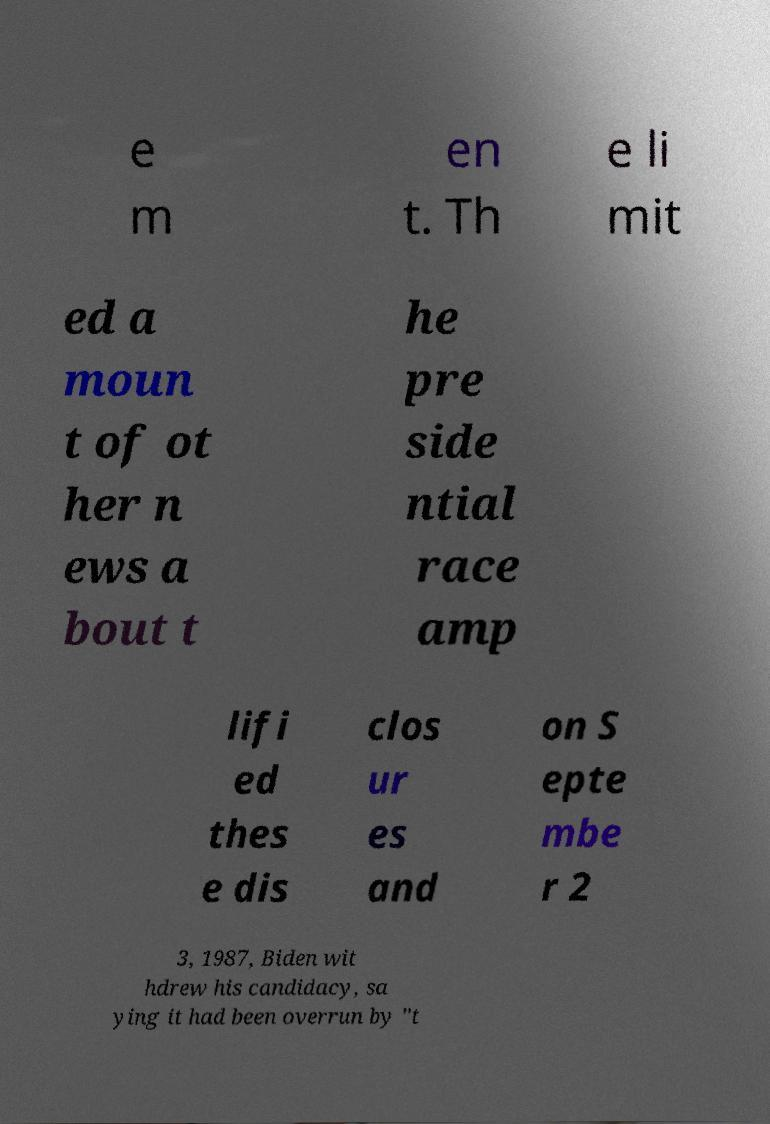There's text embedded in this image that I need extracted. Can you transcribe it verbatim? e m en t. Th e li mit ed a moun t of ot her n ews a bout t he pre side ntial race amp lifi ed thes e dis clos ur es and on S epte mbe r 2 3, 1987, Biden wit hdrew his candidacy, sa ying it had been overrun by "t 